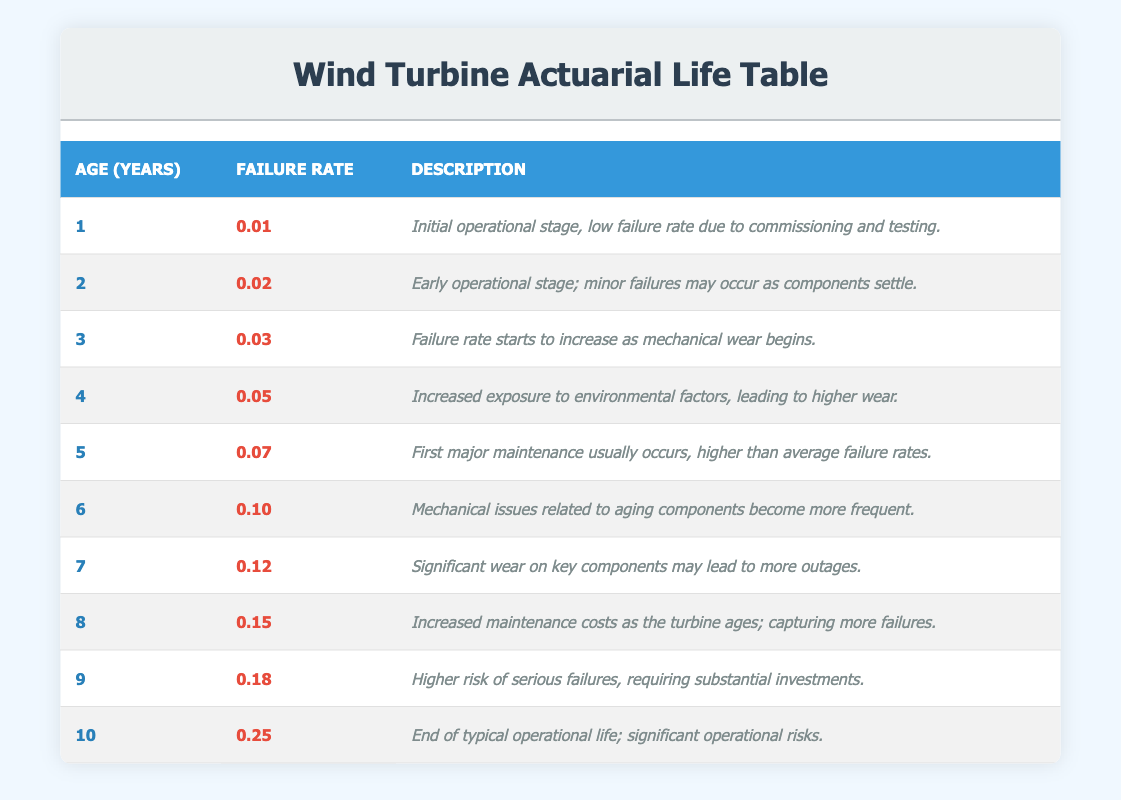What is the failure rate for wind turbines at age 4? The table indicates that the failure rate at age 4 is listed under the "Failure Rate" column corresponding to age 4 in the "Age (Years)" column. By checking this specific row, we find that the value is 0.05.
Answer: 0.05 What is the description for age 7 wind turbines? We look at the row that corresponds to age 7 in the "Age (Years)" column. The "Description" column for this row indicates that it states significant wear on key components may lead to more outages.
Answer: Significant wear on key components may lead to more outages Which age group experiences the first major maintenance? By reviewing the "Description" column, the age group that mentions the first major maintenance typically occurs corresponds to age 5. Therefore, we conclude that age 5 is the answer.
Answer: Age 5 What is the total failure rate from age 1 to age 5? To find the total failure rate from age 1 to age 5, we add the individual failure rates: 0.01 + 0.02 + 0.03 + 0.05 + 0.07 = 0.18. Thus, the total failure rate for this age range is 0.18.
Answer: 0.18 Is the failure rate at age 10 greater than the failure rate at age 8? Comparing both rates, the failure rate at age 10 is 0.25, and the failure rate at age 8 is 0.15. Since 0.25 is greater than 0.15, that confirms the statement is true.
Answer: Yes What is the average failure rate from ages 6 to 10? We need to calculate the average failure rate over these ages. The failure rates are: 0.10 (age 6), 0.12 (age 7), 0.15 (age 8), 0.18 (age 9), and 0.25 (age 10). Sum these values: 0.10 + 0.12 + 0.15 + 0.18 + 0.25 = 0.80. There are 5 values, so the average is 0.80 / 5 = 0.16.
Answer: 0.16 At what age does the failure rate first exceed 0.10? By reviewing the failure rates listed, we see they are as follows: 0.01 (age 1), 0.02 (age 2), 0.03 (age 3), 0.05 (age 4), 0.07 (age 5), 0.10 (age 6), 0.12 (age 7). The first instance when the failure rate exceeds 0.10 occurs at age 7 with a rate of 0.12.
Answer: Age 7 Are there any ages where the failure rate is exactly 0.20? Looking through the "Failure Rate" column, we observe that the failure rates listed do not include a value of 0.20, therefore the answer is no.
Answer: No What is the difference between the failure rate at age 9 and age 6? The failure rate at age 9 is 0.18, and at age 6 it is 0.10. The difference can be calculated as: 0.18 - 0.10 = 0.08. Therefore, the answer is that the difference is 0.08.
Answer: 0.08 